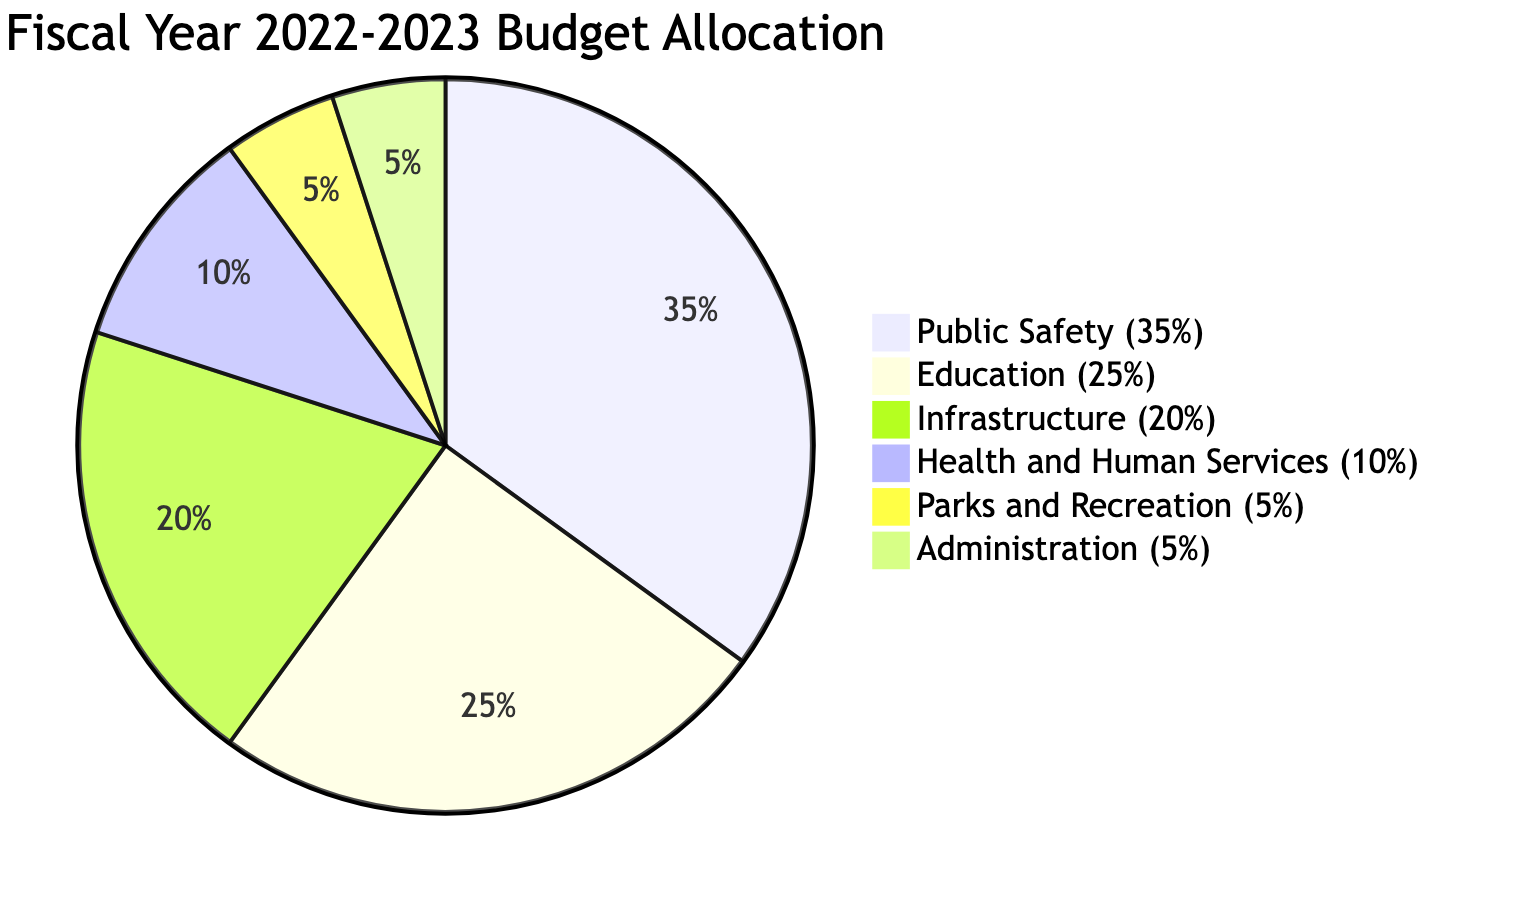What percentage of the budget is allocated to Public Safety? The diagram indicates that Public Safety has a slice representing 35% of the total budget allocation.
Answer: 35% What is the total percentage allocated to Education and Health and Human Services combined? Education is allocated 25% and Health and Human Services is allocated 10%. Adding these together gives 25% + 10% = 35%.
Answer: 35% Which department has the smallest budget allocation? The smallest allocations are for Parks and Recreation and Administration, both at 5%.
Answer: Parks and Recreation How many departments are listed in the budget allocation? The diagram includes six distinct departments: Public Safety, Education, Infrastructure, Health and Human Services, Parks and Recreation, and Administration. Counting these gives a total of 6.
Answer: 6 What is the difference in budget allocation between Infrastructure and Health and Human Services? The budget for Infrastructure is 20% and for Health and Human Services is 10%. The difference is 20% - 10% = 10%.
Answer: 10% What department receives the highest portion of the budget? The highest portion of the budget is allocated to Public Safety at 35%.
Answer: Public Safety How does the allocation for Education compare to that of Parks and Recreation? Education is allocated 25% while Parks and Recreation is allocated 5%. The comparison shows that Education receives 20% more than Parks and Recreation.
Answer: 20% more Which two departments together have more than 50% of the total budget? Public Safety (35%) and Education (25%) combined total 60%, which is more than 50%.
Answer: Public Safety and Education What is the combined percentage allocation for Infrastructure, Parks and Recreation, and Administration? Infrastructure is 20%, Parks and Recreation is 5%, and Administration is 5%. Adding these together gives 20% + 5% + 5% = 30%.
Answer: 30% 